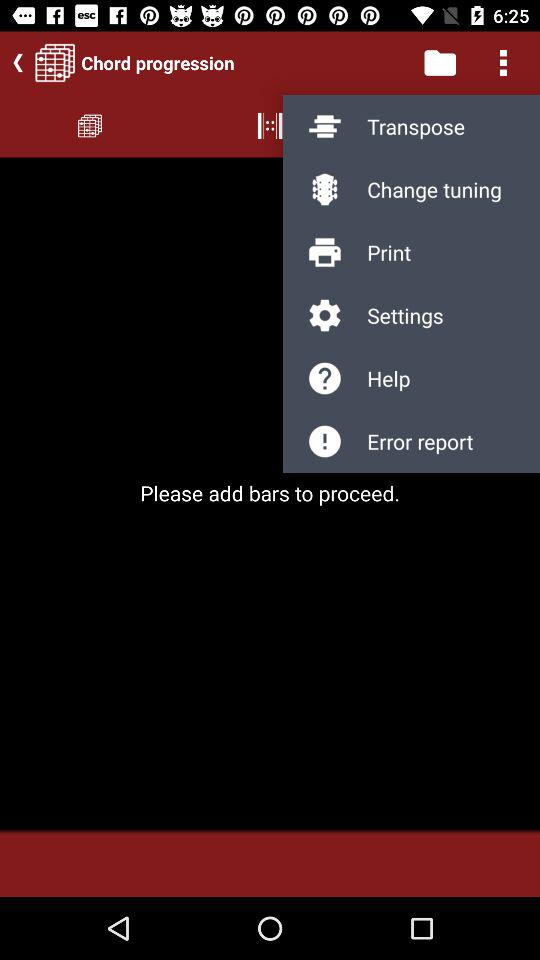What is the application name?
When the provided information is insufficient, respond with <no answer>. <no answer> 